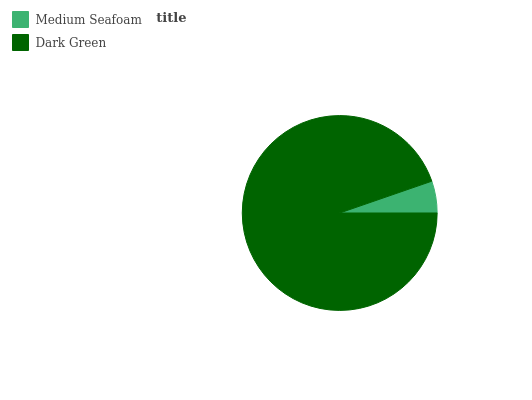Is Medium Seafoam the minimum?
Answer yes or no. Yes. Is Dark Green the maximum?
Answer yes or no. Yes. Is Dark Green the minimum?
Answer yes or no. No. Is Dark Green greater than Medium Seafoam?
Answer yes or no. Yes. Is Medium Seafoam less than Dark Green?
Answer yes or no. Yes. Is Medium Seafoam greater than Dark Green?
Answer yes or no. No. Is Dark Green less than Medium Seafoam?
Answer yes or no. No. Is Dark Green the high median?
Answer yes or no. Yes. Is Medium Seafoam the low median?
Answer yes or no. Yes. Is Medium Seafoam the high median?
Answer yes or no. No. Is Dark Green the low median?
Answer yes or no. No. 